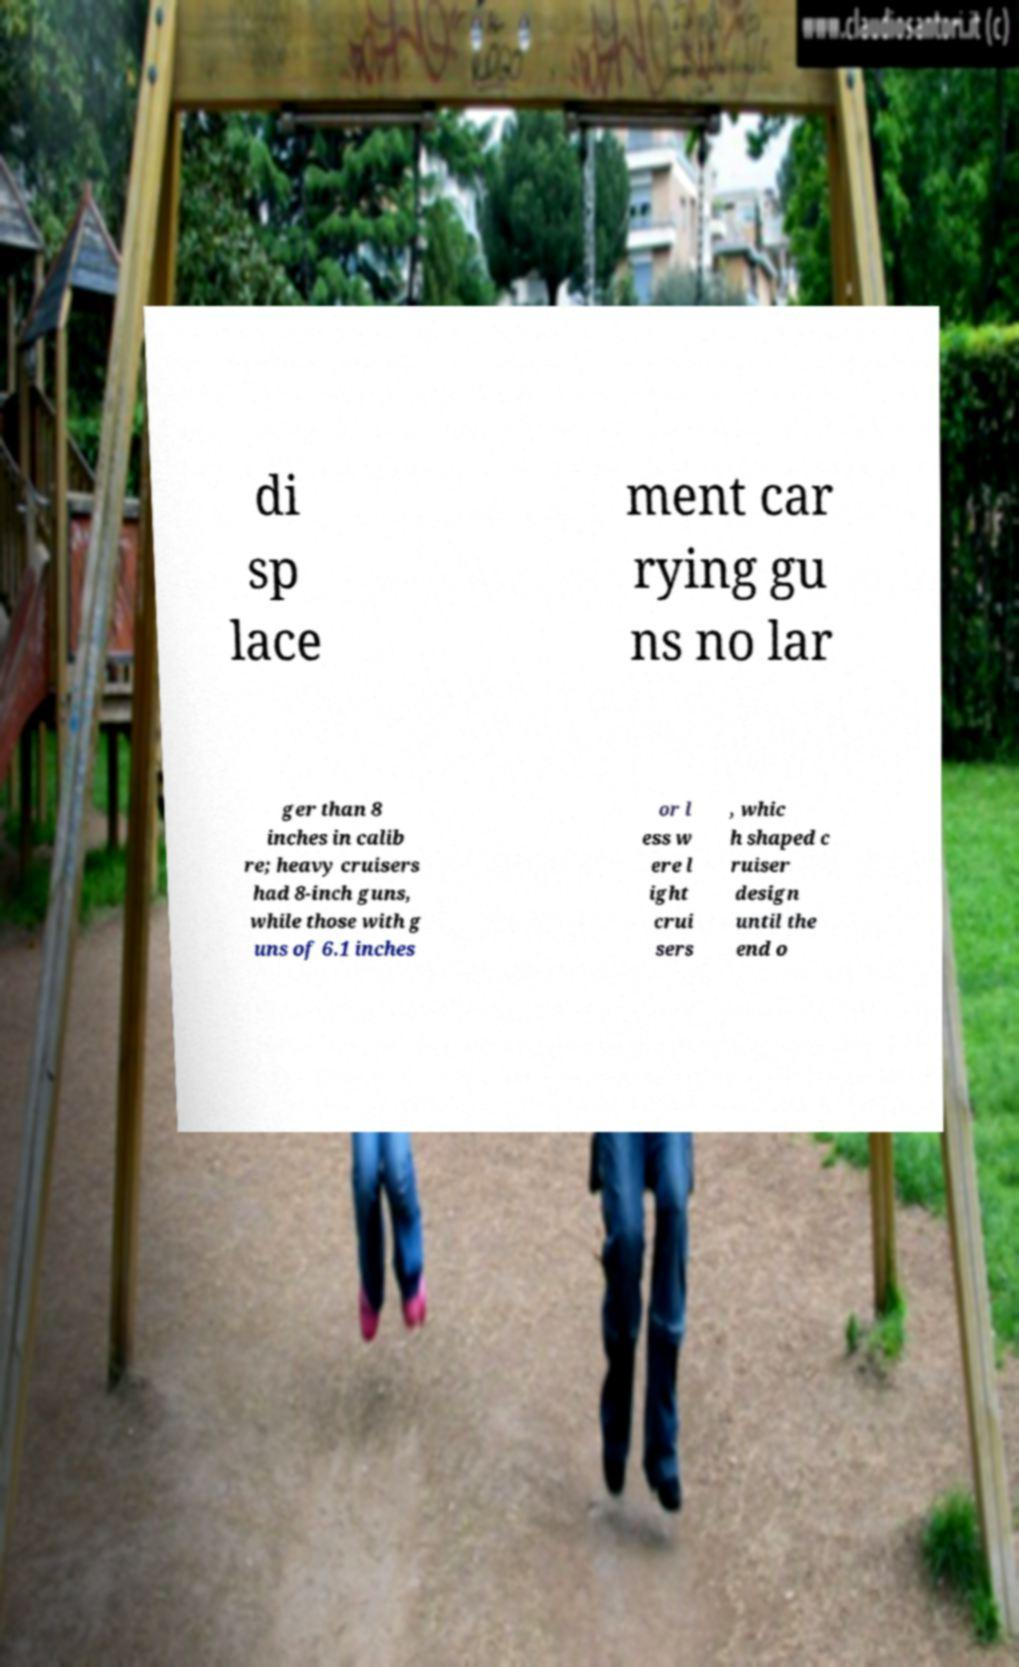Please identify and transcribe the text found in this image. di sp lace ment car rying gu ns no lar ger than 8 inches in calib re; heavy cruisers had 8-inch guns, while those with g uns of 6.1 inches or l ess w ere l ight crui sers , whic h shaped c ruiser design until the end o 